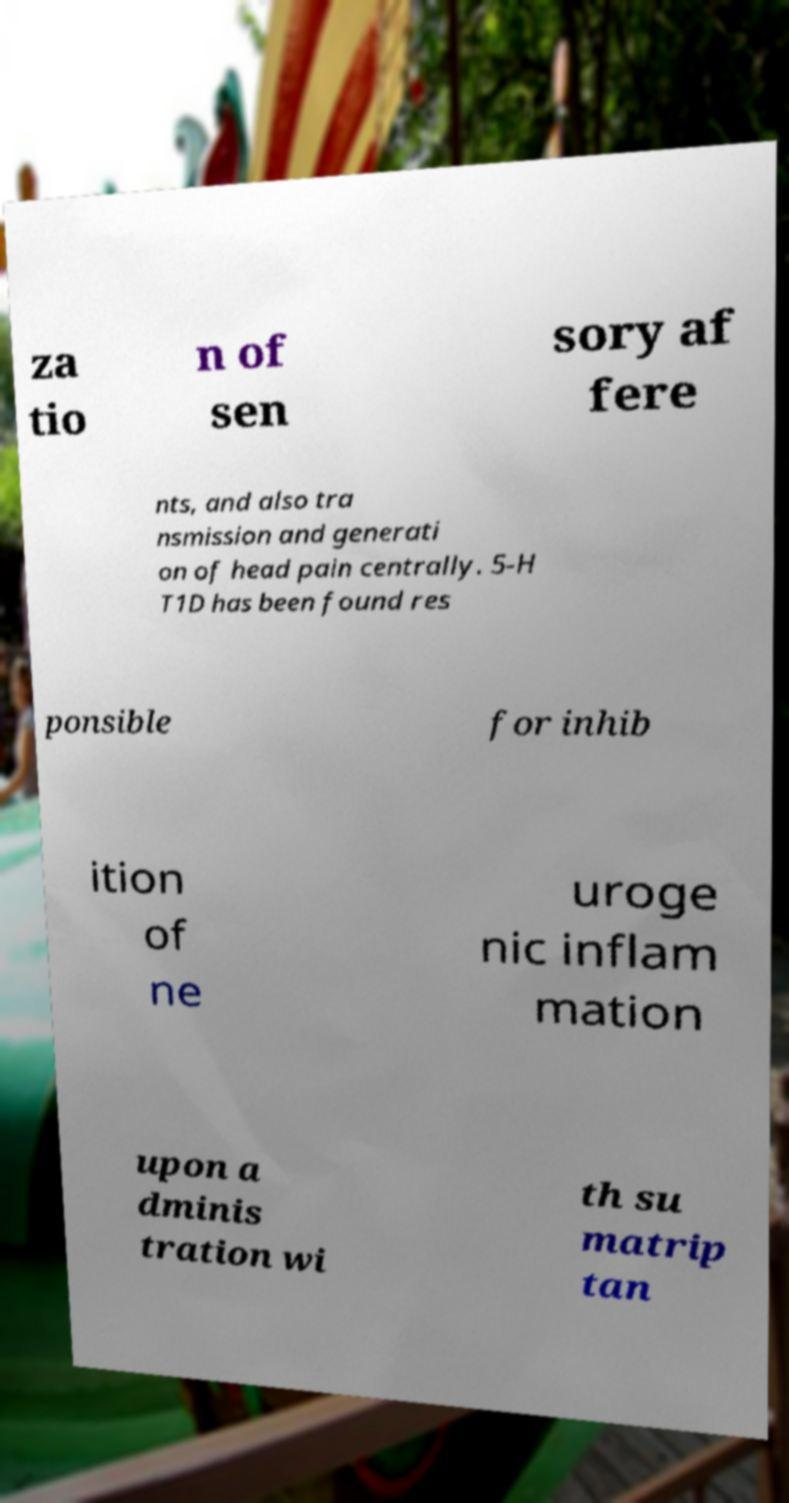There's text embedded in this image that I need extracted. Can you transcribe it verbatim? za tio n of sen sory af fere nts, and also tra nsmission and generati on of head pain centrally. 5-H T1D has been found res ponsible for inhib ition of ne uroge nic inflam mation upon a dminis tration wi th su matrip tan 